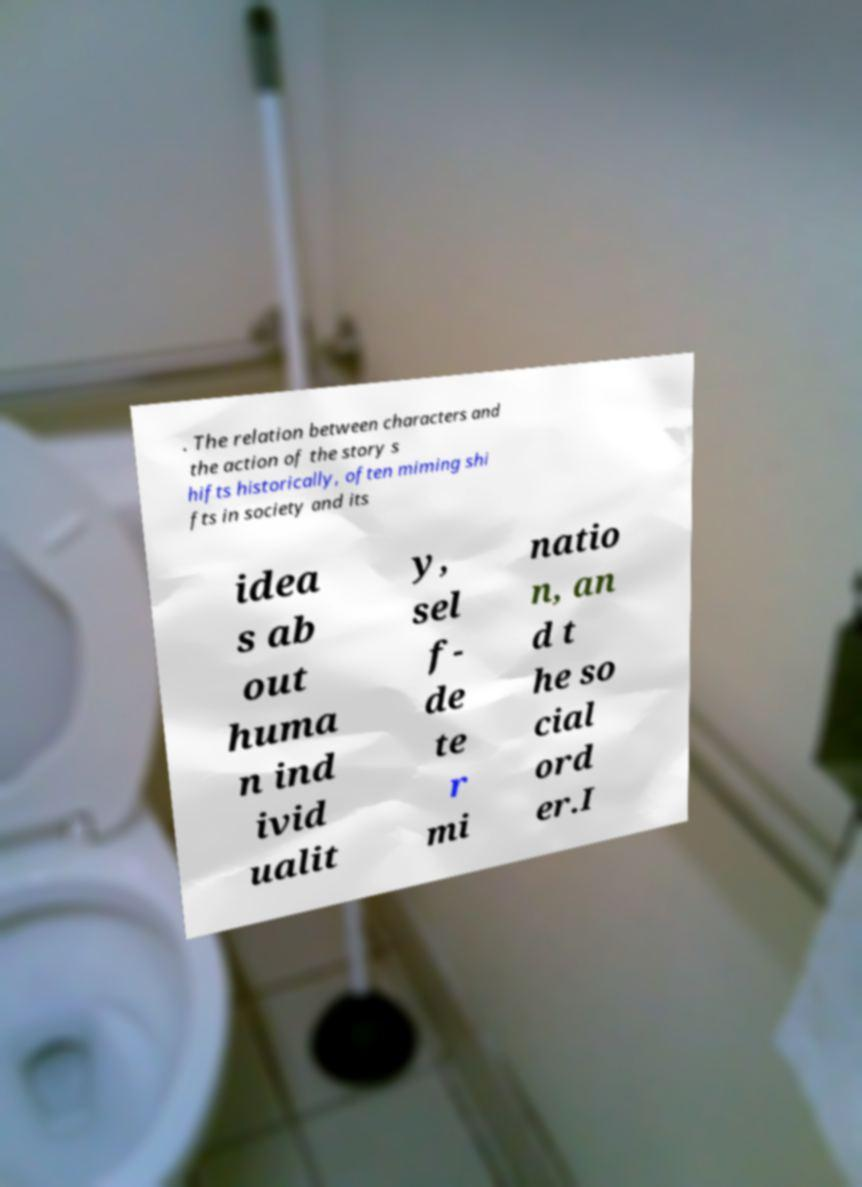Can you accurately transcribe the text from the provided image for me? . The relation between characters and the action of the story s hifts historically, often miming shi fts in society and its idea s ab out huma n ind ivid ualit y, sel f- de te r mi natio n, an d t he so cial ord er.I 